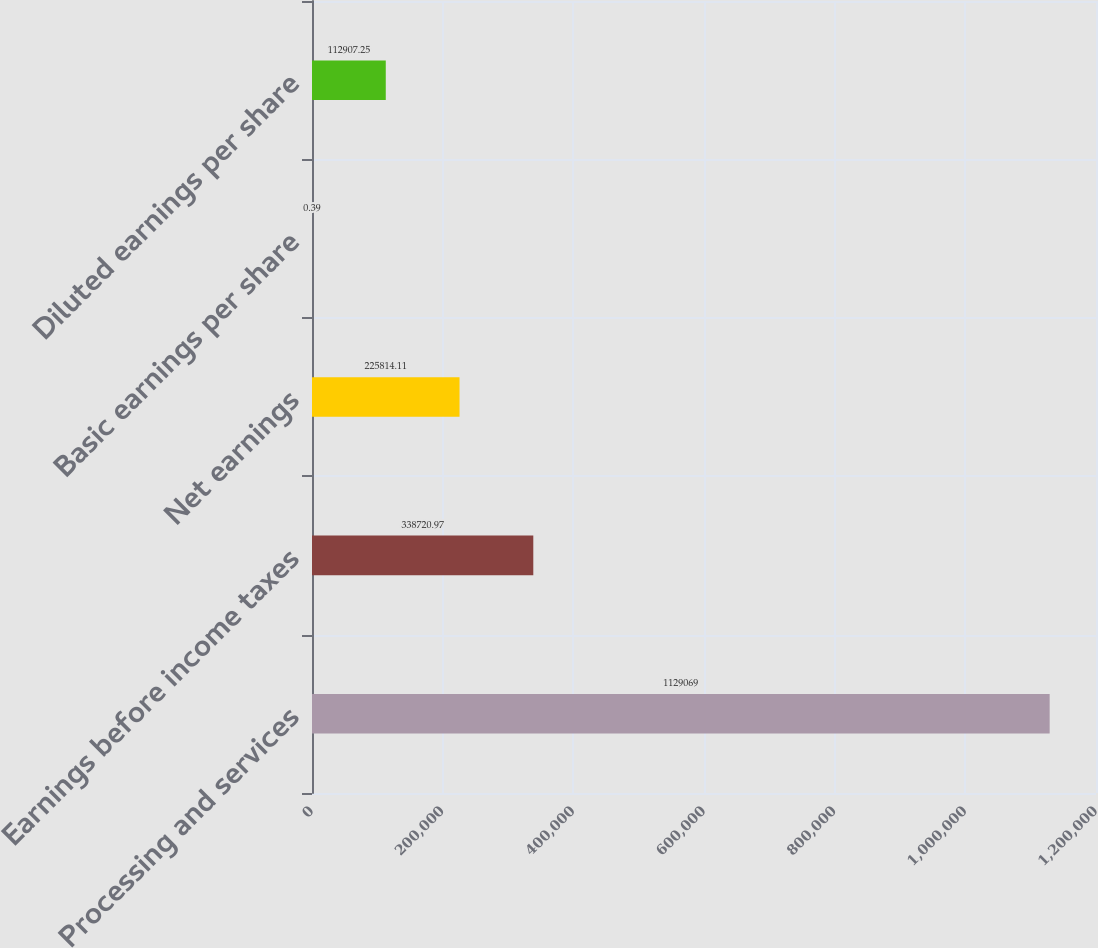<chart> <loc_0><loc_0><loc_500><loc_500><bar_chart><fcel>Processing and services<fcel>Earnings before income taxes<fcel>Net earnings<fcel>Basic earnings per share<fcel>Diluted earnings per share<nl><fcel>1.12907e+06<fcel>338721<fcel>225814<fcel>0.39<fcel>112907<nl></chart> 